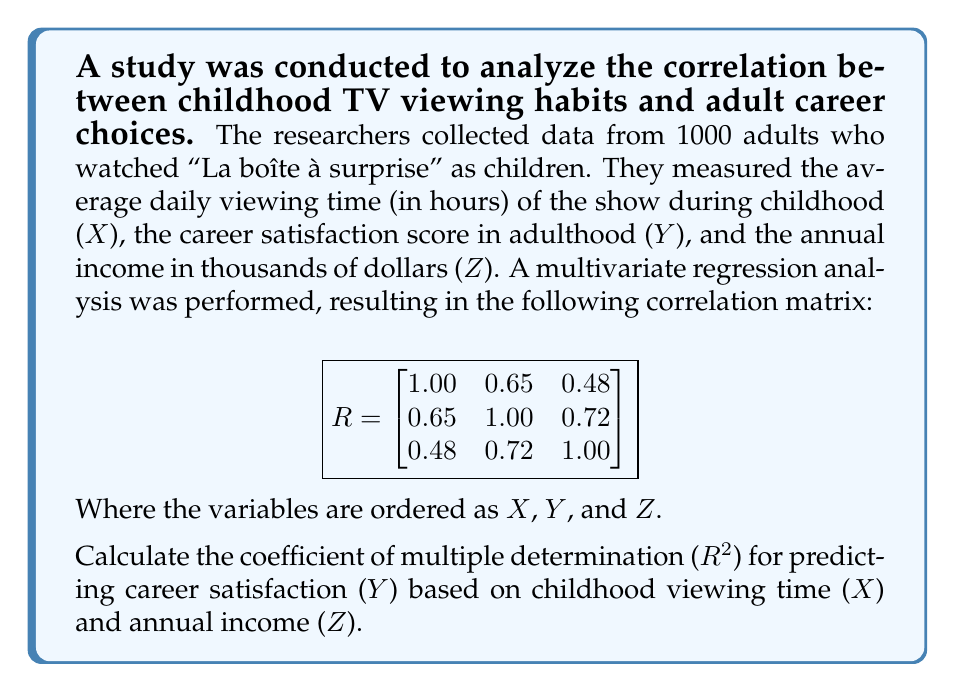Help me with this question. To calculate the coefficient of multiple determination (R²) for predicting Y based on X and Z, we'll follow these steps:

1. The correlation matrix R is given as:

$$
R = \begin{bmatrix}
1.00 & 0.65 & 0.48 \\
0.65 & 1.00 & 0.72 \\
0.48 & 0.72 & 1.00
\end{bmatrix}
$$

2. We need to partition this matrix into submatrices:

   $r_{yy} = 1.00$ (correlation of Y with itself)
   $r_{yx} = [0.65 \quad 0.72]$ (correlations of Y with X and Z)
   $R_{xx} = \begin{bmatrix} 1.00 & 0.48 \\ 0.48 & 1.00 \end{bmatrix}$ (correlations among X and Z)

3. The formula for R² in multivariate regression is:

   $R^2 = r_{yx} R_{xx}^{-1} r_{yx}^T$

4. First, we need to find $R_{xx}^{-1}$:

   $R_{xx}^{-1} = \frac{1}{1.00^2 - 0.48^2} \begin{bmatrix} 1.00 & -0.48 \\ -0.48 & 1.00 \end{bmatrix} = \begin{bmatrix} 1.3 & -0.624 \\ -0.624 & 1.3 \end{bmatrix}$

5. Now we can calculate R²:

   $R^2 = [0.65 \quad 0.72] \begin{bmatrix} 1.3 & -0.624 \\ -0.624 & 1.3 \end{bmatrix} \begin{bmatrix} 0.65 \\ 0.72 \end{bmatrix}$

   $R^2 = [0.65(1.3) + 0.72(-0.624) \quad 0.65(-0.624) + 0.72(1.3)] \begin{bmatrix} 0.65 \\ 0.72 \end{bmatrix}$

   $R^2 = [0.845 - 0.44928 \quad -0.4056 + 0.936] \begin{bmatrix} 0.65 \\ 0.72 \end{bmatrix}$

   $R^2 = [0.39572 \quad 0.5304] \begin{bmatrix} 0.65 \\ 0.72 \end{bmatrix}$

   $R^2 = 0.39572(0.65) + 0.5304(0.72)$

   $R^2 = 0.257218 + 0.381888 = 0.639106$

6. Therefore, the coefficient of multiple determination (R²) is approximately 0.6391 or 63.91%.
Answer: $R^2 \approx 0.6391$ 